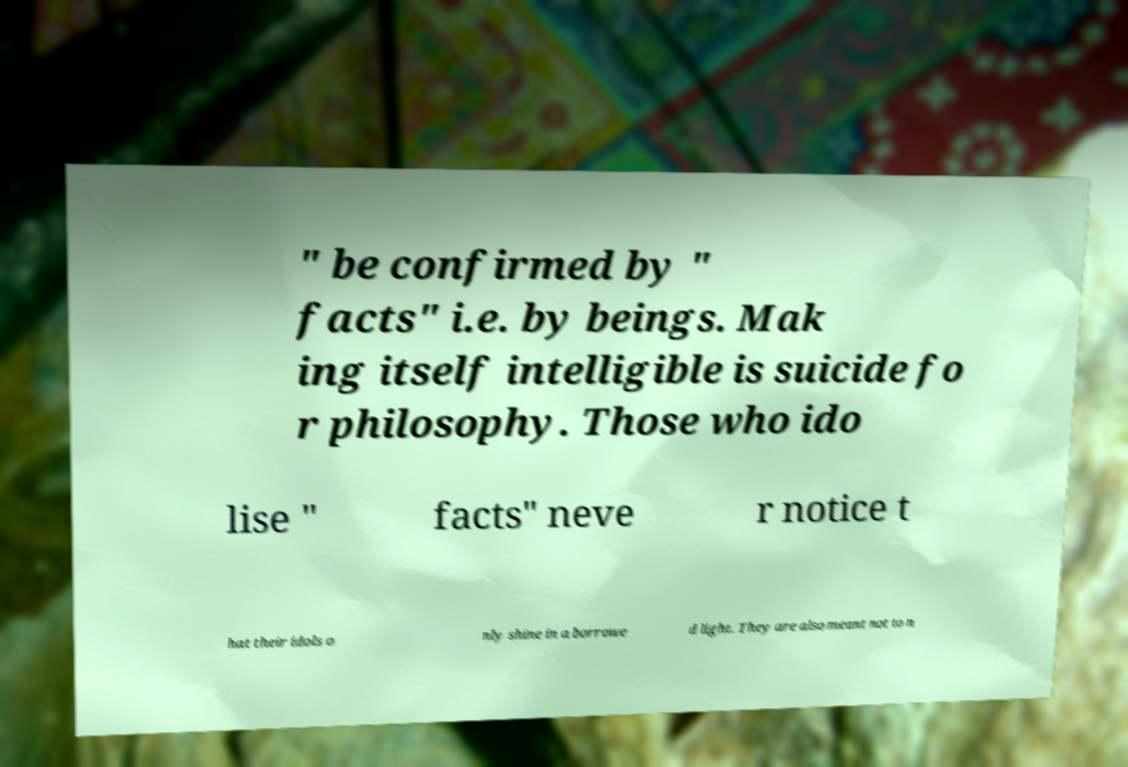There's text embedded in this image that I need extracted. Can you transcribe it verbatim? " be confirmed by " facts" i.e. by beings. Mak ing itself intelligible is suicide fo r philosophy. Those who ido lise " facts" neve r notice t hat their idols o nly shine in a borrowe d light. They are also meant not to n 